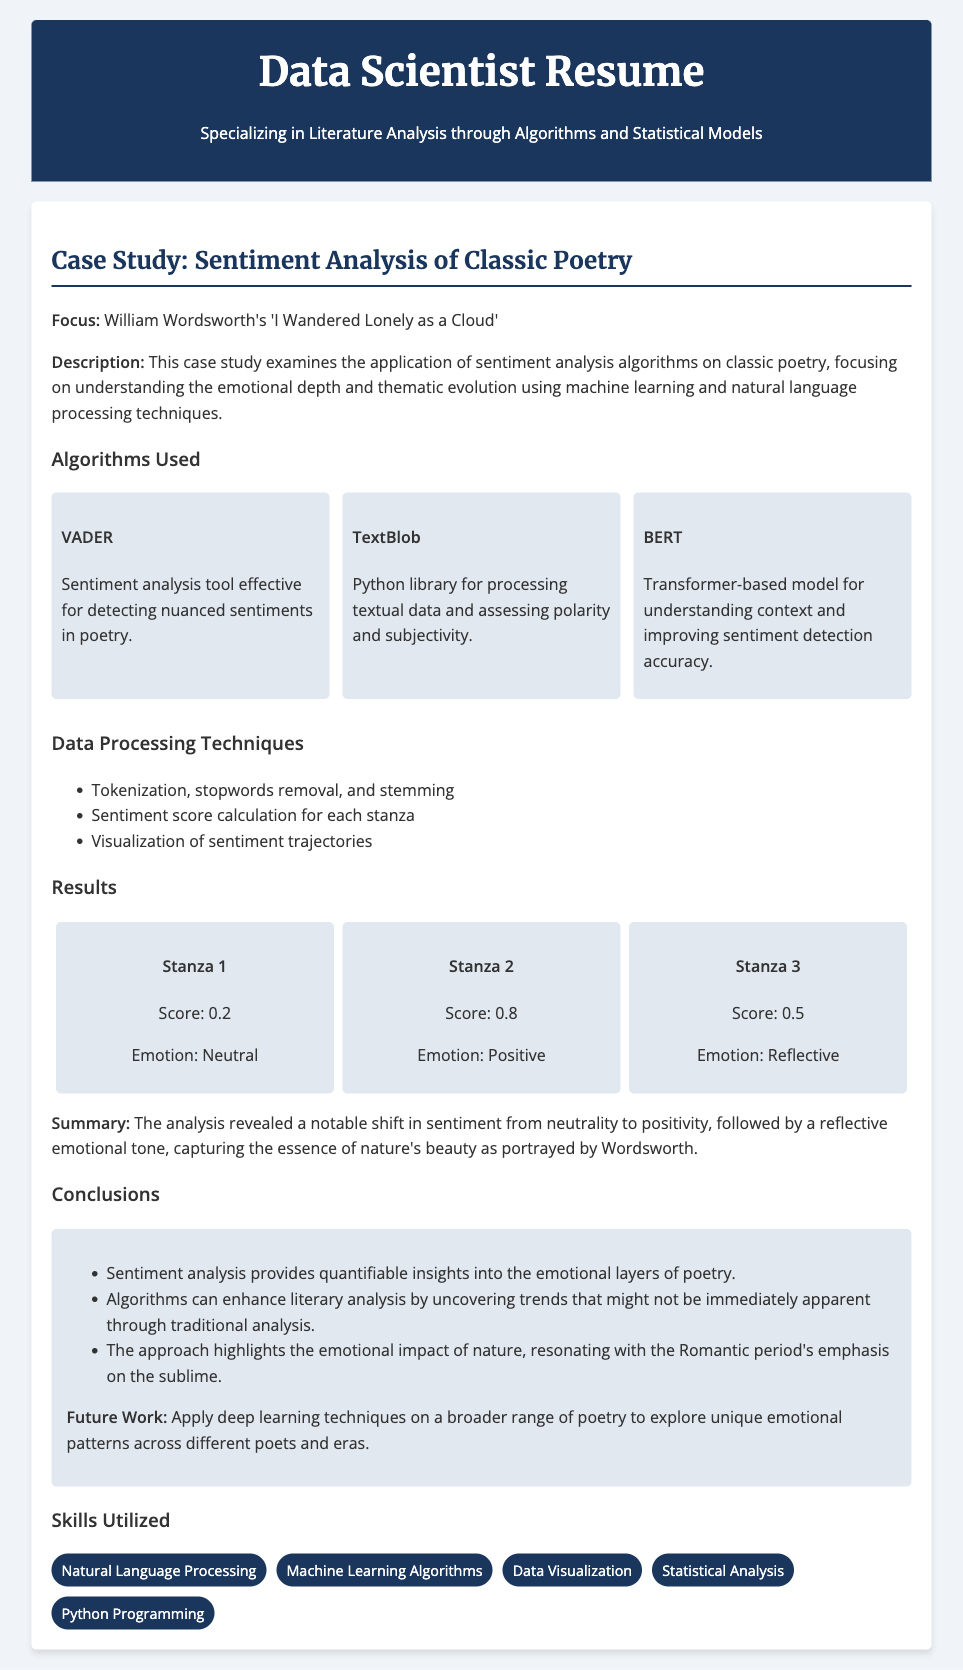What is the title of the case study? The title of the case study is mentioned in the document as "Case Study: Sentiment Analysis of Classic Poetry."
Answer: Case Study: Sentiment Analysis of Classic Poetry Who is the poet analyzed in this case study? The document specifies that the focus of the case study is on William Wordsworth's poem.
Answer: William Wordsworth What is the sentiment score for Stanza 2? The sentiment score is provided in the results section for each stanza, with Stanza 2 scoring 0.8.
Answer: 0.8 What technique was used for sentiment score calculation? The document describes the data processing technique used for sentiment score calculation and mentions it explicitly in a list.
Answer: Sentiment score calculation for each stanza What future work is suggested in the conclusions? The future work mentioned in the conclusions discusses applying deep learning techniques on more poetry to explore emotional patterns.
Answer: Apply deep learning techniques on a broader range of poetry Which algorithm is described as a transformer-based model? The document lists algorithms used in the case study, identifying BERT as the transformer-based model focused on context.
Answer: BERT What emotional tone does the analysis reveal for Stanza 3? The emotional tone is highlighted in the results for Stanza 3, noting it as reflective.
Answer: Reflective Which skill is highlighted first in the skills utilized section? The skills section lists various skills utilized, starting with Natural Language Processing.
Answer: Natural Language Processing 